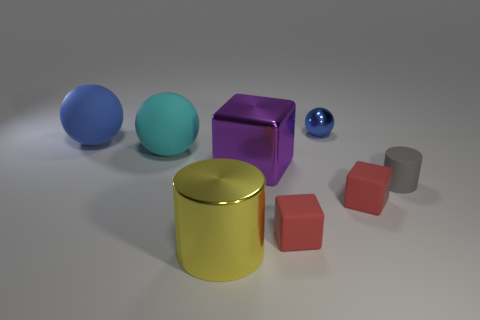Add 1 red objects. How many objects exist? 9 Subtract all cylinders. How many objects are left? 6 Subtract 2 blue balls. How many objects are left? 6 Subtract all yellow things. Subtract all tiny blue objects. How many objects are left? 6 Add 8 yellow metal cylinders. How many yellow metal cylinders are left? 9 Add 7 small yellow spheres. How many small yellow spheres exist? 7 